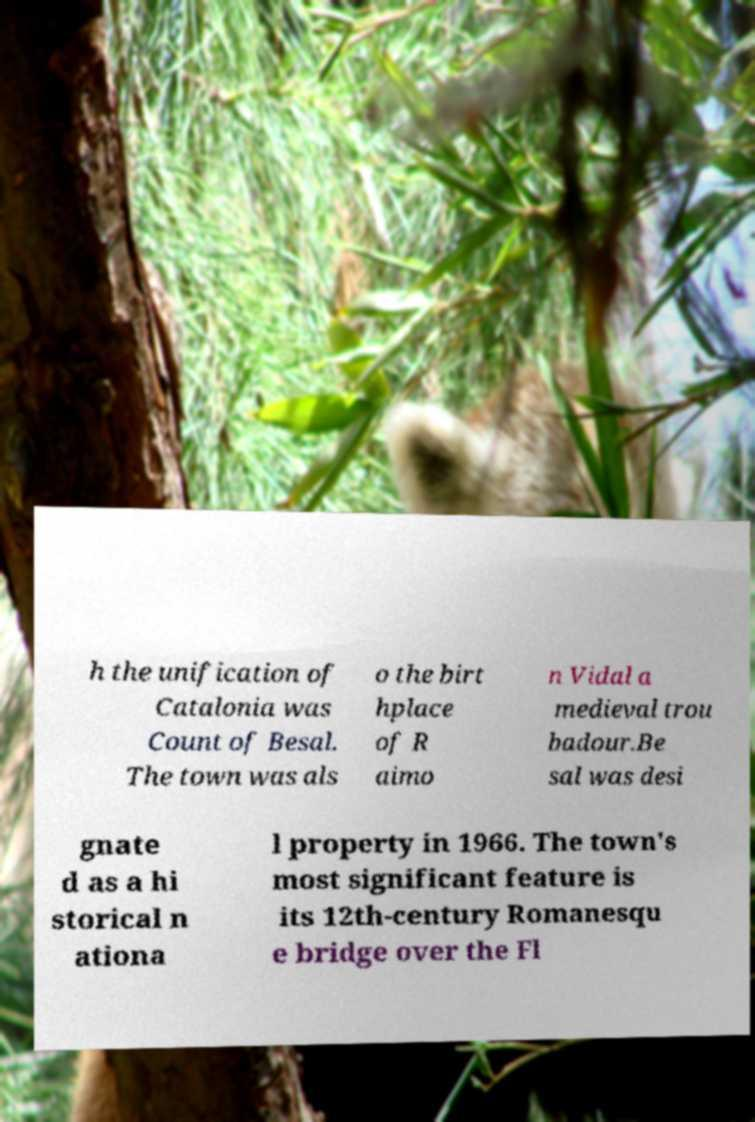For documentation purposes, I need the text within this image transcribed. Could you provide that? h the unification of Catalonia was Count of Besal. The town was als o the birt hplace of R aimo n Vidal a medieval trou badour.Be sal was desi gnate d as a hi storical n ationa l property in 1966. The town's most significant feature is its 12th-century Romanesqu e bridge over the Fl 